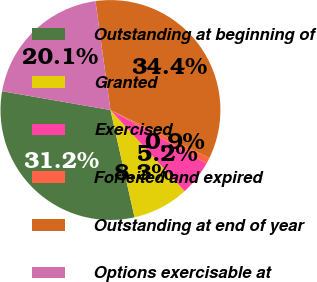Convert chart. <chart><loc_0><loc_0><loc_500><loc_500><pie_chart><fcel>Outstanding at beginning of<fcel>Granted<fcel>Exercised<fcel>Forfeited and expired<fcel>Outstanding at end of year<fcel>Options exercisable at<nl><fcel>31.25%<fcel>8.26%<fcel>5.15%<fcel>0.89%<fcel>34.36%<fcel>20.09%<nl></chart> 